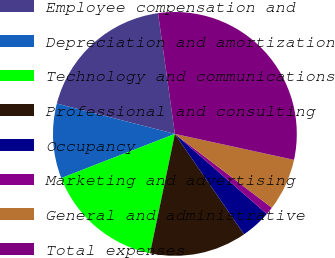<chart> <loc_0><loc_0><loc_500><loc_500><pie_chart><fcel>Employee compensation and<fcel>Depreciation and amortization<fcel>Technology and communications<fcel>Professional and consulting<fcel>Occupancy<fcel>Marketing and advertising<fcel>General and administrative<fcel>Total expenses<nl><fcel>18.79%<fcel>9.91%<fcel>15.83%<fcel>12.87%<fcel>4.0%<fcel>1.04%<fcel>6.95%<fcel>30.62%<nl></chart> 